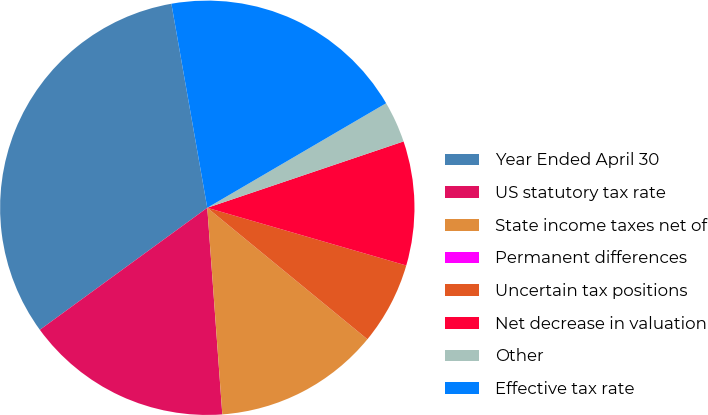Convert chart. <chart><loc_0><loc_0><loc_500><loc_500><pie_chart><fcel>Year Ended April 30<fcel>US statutory tax rate<fcel>State income taxes net of<fcel>Permanent differences<fcel>Uncertain tax positions<fcel>Net decrease in valuation<fcel>Other<fcel>Effective tax rate<nl><fcel>32.25%<fcel>16.13%<fcel>12.9%<fcel>0.0%<fcel>6.45%<fcel>9.68%<fcel>3.23%<fcel>19.35%<nl></chart> 